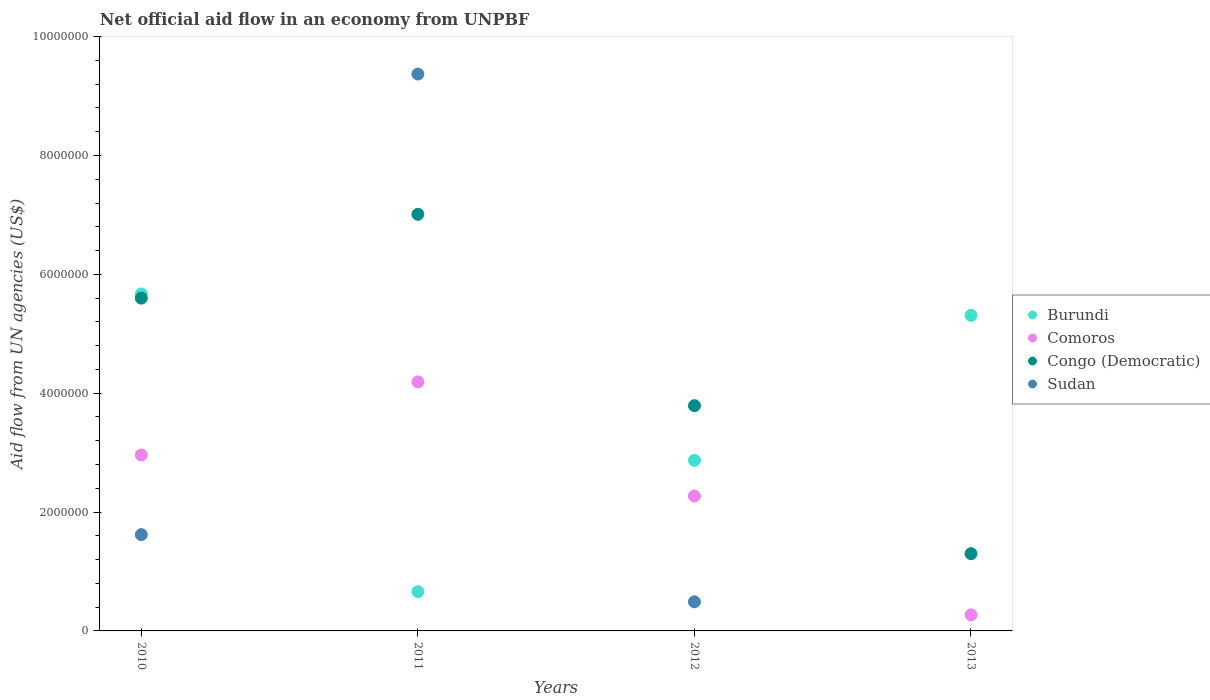How many different coloured dotlines are there?
Give a very brief answer. 4. What is the net official aid flow in Burundi in 2011?
Keep it short and to the point. 6.60e+05. Across all years, what is the maximum net official aid flow in Congo (Democratic)?
Provide a short and direct response. 7.01e+06. Across all years, what is the minimum net official aid flow in Congo (Democratic)?
Ensure brevity in your answer.  1.30e+06. What is the total net official aid flow in Comoros in the graph?
Provide a succinct answer. 9.69e+06. What is the difference between the net official aid flow in Congo (Democratic) in 2010 and that in 2013?
Provide a short and direct response. 4.30e+06. What is the difference between the net official aid flow in Comoros in 2013 and the net official aid flow in Burundi in 2010?
Your response must be concise. -5.40e+06. What is the average net official aid flow in Congo (Democratic) per year?
Provide a succinct answer. 4.42e+06. In the year 2012, what is the difference between the net official aid flow in Congo (Democratic) and net official aid flow in Burundi?
Provide a succinct answer. 9.20e+05. What is the ratio of the net official aid flow in Burundi in 2010 to that in 2012?
Your answer should be very brief. 1.98. What is the difference between the highest and the second highest net official aid flow in Burundi?
Your response must be concise. 3.60e+05. What is the difference between the highest and the lowest net official aid flow in Congo (Democratic)?
Keep it short and to the point. 5.71e+06. Is it the case that in every year, the sum of the net official aid flow in Burundi and net official aid flow in Comoros  is greater than the sum of net official aid flow in Sudan and net official aid flow in Congo (Democratic)?
Keep it short and to the point. No. Is it the case that in every year, the sum of the net official aid flow in Sudan and net official aid flow in Burundi  is greater than the net official aid flow in Congo (Democratic)?
Provide a short and direct response. No. Does the net official aid flow in Congo (Democratic) monotonically increase over the years?
Ensure brevity in your answer.  No. Is the net official aid flow in Congo (Democratic) strictly less than the net official aid flow in Sudan over the years?
Offer a terse response. No. What is the difference between two consecutive major ticks on the Y-axis?
Provide a short and direct response. 2.00e+06. How many legend labels are there?
Keep it short and to the point. 4. How are the legend labels stacked?
Ensure brevity in your answer.  Vertical. What is the title of the graph?
Ensure brevity in your answer.  Net official aid flow in an economy from UNPBF. What is the label or title of the Y-axis?
Your response must be concise. Aid flow from UN agencies (US$). What is the Aid flow from UN agencies (US$) of Burundi in 2010?
Offer a terse response. 5.67e+06. What is the Aid flow from UN agencies (US$) of Comoros in 2010?
Ensure brevity in your answer.  2.96e+06. What is the Aid flow from UN agencies (US$) of Congo (Democratic) in 2010?
Your answer should be very brief. 5.60e+06. What is the Aid flow from UN agencies (US$) in Sudan in 2010?
Your response must be concise. 1.62e+06. What is the Aid flow from UN agencies (US$) in Comoros in 2011?
Keep it short and to the point. 4.19e+06. What is the Aid flow from UN agencies (US$) in Congo (Democratic) in 2011?
Keep it short and to the point. 7.01e+06. What is the Aid flow from UN agencies (US$) of Sudan in 2011?
Make the answer very short. 9.37e+06. What is the Aid flow from UN agencies (US$) in Burundi in 2012?
Your answer should be very brief. 2.87e+06. What is the Aid flow from UN agencies (US$) of Comoros in 2012?
Offer a very short reply. 2.27e+06. What is the Aid flow from UN agencies (US$) of Congo (Democratic) in 2012?
Offer a terse response. 3.79e+06. What is the Aid flow from UN agencies (US$) in Sudan in 2012?
Provide a succinct answer. 4.90e+05. What is the Aid flow from UN agencies (US$) in Burundi in 2013?
Your answer should be very brief. 5.31e+06. What is the Aid flow from UN agencies (US$) in Congo (Democratic) in 2013?
Provide a short and direct response. 1.30e+06. What is the Aid flow from UN agencies (US$) in Sudan in 2013?
Your answer should be very brief. 0. Across all years, what is the maximum Aid flow from UN agencies (US$) in Burundi?
Provide a short and direct response. 5.67e+06. Across all years, what is the maximum Aid flow from UN agencies (US$) of Comoros?
Offer a very short reply. 4.19e+06. Across all years, what is the maximum Aid flow from UN agencies (US$) of Congo (Democratic)?
Your answer should be very brief. 7.01e+06. Across all years, what is the maximum Aid flow from UN agencies (US$) in Sudan?
Give a very brief answer. 9.37e+06. Across all years, what is the minimum Aid flow from UN agencies (US$) in Burundi?
Make the answer very short. 6.60e+05. Across all years, what is the minimum Aid flow from UN agencies (US$) in Congo (Democratic)?
Your answer should be very brief. 1.30e+06. What is the total Aid flow from UN agencies (US$) of Burundi in the graph?
Your response must be concise. 1.45e+07. What is the total Aid flow from UN agencies (US$) in Comoros in the graph?
Your response must be concise. 9.69e+06. What is the total Aid flow from UN agencies (US$) of Congo (Democratic) in the graph?
Offer a very short reply. 1.77e+07. What is the total Aid flow from UN agencies (US$) in Sudan in the graph?
Keep it short and to the point. 1.15e+07. What is the difference between the Aid flow from UN agencies (US$) in Burundi in 2010 and that in 2011?
Offer a terse response. 5.01e+06. What is the difference between the Aid flow from UN agencies (US$) in Comoros in 2010 and that in 2011?
Offer a very short reply. -1.23e+06. What is the difference between the Aid flow from UN agencies (US$) of Congo (Democratic) in 2010 and that in 2011?
Your answer should be compact. -1.41e+06. What is the difference between the Aid flow from UN agencies (US$) of Sudan in 2010 and that in 2011?
Your answer should be very brief. -7.75e+06. What is the difference between the Aid flow from UN agencies (US$) of Burundi in 2010 and that in 2012?
Your answer should be very brief. 2.80e+06. What is the difference between the Aid flow from UN agencies (US$) of Comoros in 2010 and that in 2012?
Give a very brief answer. 6.90e+05. What is the difference between the Aid flow from UN agencies (US$) in Congo (Democratic) in 2010 and that in 2012?
Your response must be concise. 1.81e+06. What is the difference between the Aid flow from UN agencies (US$) in Sudan in 2010 and that in 2012?
Keep it short and to the point. 1.13e+06. What is the difference between the Aid flow from UN agencies (US$) of Comoros in 2010 and that in 2013?
Keep it short and to the point. 2.69e+06. What is the difference between the Aid flow from UN agencies (US$) of Congo (Democratic) in 2010 and that in 2013?
Make the answer very short. 4.30e+06. What is the difference between the Aid flow from UN agencies (US$) of Burundi in 2011 and that in 2012?
Your response must be concise. -2.21e+06. What is the difference between the Aid flow from UN agencies (US$) in Comoros in 2011 and that in 2012?
Provide a succinct answer. 1.92e+06. What is the difference between the Aid flow from UN agencies (US$) of Congo (Democratic) in 2011 and that in 2012?
Provide a short and direct response. 3.22e+06. What is the difference between the Aid flow from UN agencies (US$) in Sudan in 2011 and that in 2012?
Give a very brief answer. 8.88e+06. What is the difference between the Aid flow from UN agencies (US$) in Burundi in 2011 and that in 2013?
Your response must be concise. -4.65e+06. What is the difference between the Aid flow from UN agencies (US$) in Comoros in 2011 and that in 2013?
Your response must be concise. 3.92e+06. What is the difference between the Aid flow from UN agencies (US$) of Congo (Democratic) in 2011 and that in 2013?
Make the answer very short. 5.71e+06. What is the difference between the Aid flow from UN agencies (US$) of Burundi in 2012 and that in 2013?
Offer a very short reply. -2.44e+06. What is the difference between the Aid flow from UN agencies (US$) in Comoros in 2012 and that in 2013?
Your answer should be very brief. 2.00e+06. What is the difference between the Aid flow from UN agencies (US$) of Congo (Democratic) in 2012 and that in 2013?
Give a very brief answer. 2.49e+06. What is the difference between the Aid flow from UN agencies (US$) of Burundi in 2010 and the Aid flow from UN agencies (US$) of Comoros in 2011?
Offer a very short reply. 1.48e+06. What is the difference between the Aid flow from UN agencies (US$) in Burundi in 2010 and the Aid flow from UN agencies (US$) in Congo (Democratic) in 2011?
Give a very brief answer. -1.34e+06. What is the difference between the Aid flow from UN agencies (US$) in Burundi in 2010 and the Aid flow from UN agencies (US$) in Sudan in 2011?
Provide a succinct answer. -3.70e+06. What is the difference between the Aid flow from UN agencies (US$) of Comoros in 2010 and the Aid flow from UN agencies (US$) of Congo (Democratic) in 2011?
Give a very brief answer. -4.05e+06. What is the difference between the Aid flow from UN agencies (US$) in Comoros in 2010 and the Aid flow from UN agencies (US$) in Sudan in 2011?
Your answer should be compact. -6.41e+06. What is the difference between the Aid flow from UN agencies (US$) in Congo (Democratic) in 2010 and the Aid flow from UN agencies (US$) in Sudan in 2011?
Offer a very short reply. -3.77e+06. What is the difference between the Aid flow from UN agencies (US$) in Burundi in 2010 and the Aid flow from UN agencies (US$) in Comoros in 2012?
Your answer should be very brief. 3.40e+06. What is the difference between the Aid flow from UN agencies (US$) in Burundi in 2010 and the Aid flow from UN agencies (US$) in Congo (Democratic) in 2012?
Offer a terse response. 1.88e+06. What is the difference between the Aid flow from UN agencies (US$) of Burundi in 2010 and the Aid flow from UN agencies (US$) of Sudan in 2012?
Your answer should be very brief. 5.18e+06. What is the difference between the Aid flow from UN agencies (US$) of Comoros in 2010 and the Aid flow from UN agencies (US$) of Congo (Democratic) in 2012?
Make the answer very short. -8.30e+05. What is the difference between the Aid flow from UN agencies (US$) in Comoros in 2010 and the Aid flow from UN agencies (US$) in Sudan in 2012?
Your response must be concise. 2.47e+06. What is the difference between the Aid flow from UN agencies (US$) of Congo (Democratic) in 2010 and the Aid flow from UN agencies (US$) of Sudan in 2012?
Provide a succinct answer. 5.11e+06. What is the difference between the Aid flow from UN agencies (US$) in Burundi in 2010 and the Aid flow from UN agencies (US$) in Comoros in 2013?
Your answer should be compact. 5.40e+06. What is the difference between the Aid flow from UN agencies (US$) in Burundi in 2010 and the Aid flow from UN agencies (US$) in Congo (Democratic) in 2013?
Offer a terse response. 4.37e+06. What is the difference between the Aid flow from UN agencies (US$) in Comoros in 2010 and the Aid flow from UN agencies (US$) in Congo (Democratic) in 2013?
Make the answer very short. 1.66e+06. What is the difference between the Aid flow from UN agencies (US$) in Burundi in 2011 and the Aid flow from UN agencies (US$) in Comoros in 2012?
Provide a succinct answer. -1.61e+06. What is the difference between the Aid flow from UN agencies (US$) of Burundi in 2011 and the Aid flow from UN agencies (US$) of Congo (Democratic) in 2012?
Your answer should be compact. -3.13e+06. What is the difference between the Aid flow from UN agencies (US$) in Comoros in 2011 and the Aid flow from UN agencies (US$) in Sudan in 2012?
Provide a succinct answer. 3.70e+06. What is the difference between the Aid flow from UN agencies (US$) of Congo (Democratic) in 2011 and the Aid flow from UN agencies (US$) of Sudan in 2012?
Provide a succinct answer. 6.52e+06. What is the difference between the Aid flow from UN agencies (US$) in Burundi in 2011 and the Aid flow from UN agencies (US$) in Congo (Democratic) in 2013?
Make the answer very short. -6.40e+05. What is the difference between the Aid flow from UN agencies (US$) in Comoros in 2011 and the Aid flow from UN agencies (US$) in Congo (Democratic) in 2013?
Provide a short and direct response. 2.89e+06. What is the difference between the Aid flow from UN agencies (US$) of Burundi in 2012 and the Aid flow from UN agencies (US$) of Comoros in 2013?
Keep it short and to the point. 2.60e+06. What is the difference between the Aid flow from UN agencies (US$) of Burundi in 2012 and the Aid flow from UN agencies (US$) of Congo (Democratic) in 2013?
Your response must be concise. 1.57e+06. What is the difference between the Aid flow from UN agencies (US$) of Comoros in 2012 and the Aid flow from UN agencies (US$) of Congo (Democratic) in 2013?
Give a very brief answer. 9.70e+05. What is the average Aid flow from UN agencies (US$) in Burundi per year?
Ensure brevity in your answer.  3.63e+06. What is the average Aid flow from UN agencies (US$) in Comoros per year?
Give a very brief answer. 2.42e+06. What is the average Aid flow from UN agencies (US$) of Congo (Democratic) per year?
Keep it short and to the point. 4.42e+06. What is the average Aid flow from UN agencies (US$) in Sudan per year?
Give a very brief answer. 2.87e+06. In the year 2010, what is the difference between the Aid flow from UN agencies (US$) in Burundi and Aid flow from UN agencies (US$) in Comoros?
Make the answer very short. 2.71e+06. In the year 2010, what is the difference between the Aid flow from UN agencies (US$) of Burundi and Aid flow from UN agencies (US$) of Congo (Democratic)?
Offer a terse response. 7.00e+04. In the year 2010, what is the difference between the Aid flow from UN agencies (US$) of Burundi and Aid flow from UN agencies (US$) of Sudan?
Provide a succinct answer. 4.05e+06. In the year 2010, what is the difference between the Aid flow from UN agencies (US$) of Comoros and Aid flow from UN agencies (US$) of Congo (Democratic)?
Your answer should be very brief. -2.64e+06. In the year 2010, what is the difference between the Aid flow from UN agencies (US$) in Comoros and Aid flow from UN agencies (US$) in Sudan?
Your answer should be compact. 1.34e+06. In the year 2010, what is the difference between the Aid flow from UN agencies (US$) in Congo (Democratic) and Aid flow from UN agencies (US$) in Sudan?
Offer a terse response. 3.98e+06. In the year 2011, what is the difference between the Aid flow from UN agencies (US$) of Burundi and Aid flow from UN agencies (US$) of Comoros?
Make the answer very short. -3.53e+06. In the year 2011, what is the difference between the Aid flow from UN agencies (US$) in Burundi and Aid flow from UN agencies (US$) in Congo (Democratic)?
Make the answer very short. -6.35e+06. In the year 2011, what is the difference between the Aid flow from UN agencies (US$) in Burundi and Aid flow from UN agencies (US$) in Sudan?
Offer a very short reply. -8.71e+06. In the year 2011, what is the difference between the Aid flow from UN agencies (US$) in Comoros and Aid flow from UN agencies (US$) in Congo (Democratic)?
Your answer should be compact. -2.82e+06. In the year 2011, what is the difference between the Aid flow from UN agencies (US$) of Comoros and Aid flow from UN agencies (US$) of Sudan?
Your answer should be very brief. -5.18e+06. In the year 2011, what is the difference between the Aid flow from UN agencies (US$) of Congo (Democratic) and Aid flow from UN agencies (US$) of Sudan?
Offer a very short reply. -2.36e+06. In the year 2012, what is the difference between the Aid flow from UN agencies (US$) in Burundi and Aid flow from UN agencies (US$) in Congo (Democratic)?
Provide a short and direct response. -9.20e+05. In the year 2012, what is the difference between the Aid flow from UN agencies (US$) of Burundi and Aid flow from UN agencies (US$) of Sudan?
Ensure brevity in your answer.  2.38e+06. In the year 2012, what is the difference between the Aid flow from UN agencies (US$) in Comoros and Aid flow from UN agencies (US$) in Congo (Democratic)?
Give a very brief answer. -1.52e+06. In the year 2012, what is the difference between the Aid flow from UN agencies (US$) of Comoros and Aid flow from UN agencies (US$) of Sudan?
Your answer should be very brief. 1.78e+06. In the year 2012, what is the difference between the Aid flow from UN agencies (US$) of Congo (Democratic) and Aid flow from UN agencies (US$) of Sudan?
Make the answer very short. 3.30e+06. In the year 2013, what is the difference between the Aid flow from UN agencies (US$) of Burundi and Aid flow from UN agencies (US$) of Comoros?
Offer a very short reply. 5.04e+06. In the year 2013, what is the difference between the Aid flow from UN agencies (US$) in Burundi and Aid flow from UN agencies (US$) in Congo (Democratic)?
Your answer should be very brief. 4.01e+06. In the year 2013, what is the difference between the Aid flow from UN agencies (US$) in Comoros and Aid flow from UN agencies (US$) in Congo (Democratic)?
Give a very brief answer. -1.03e+06. What is the ratio of the Aid flow from UN agencies (US$) in Burundi in 2010 to that in 2011?
Provide a short and direct response. 8.59. What is the ratio of the Aid flow from UN agencies (US$) in Comoros in 2010 to that in 2011?
Make the answer very short. 0.71. What is the ratio of the Aid flow from UN agencies (US$) of Congo (Democratic) in 2010 to that in 2011?
Offer a very short reply. 0.8. What is the ratio of the Aid flow from UN agencies (US$) in Sudan in 2010 to that in 2011?
Give a very brief answer. 0.17. What is the ratio of the Aid flow from UN agencies (US$) of Burundi in 2010 to that in 2012?
Offer a terse response. 1.98. What is the ratio of the Aid flow from UN agencies (US$) of Comoros in 2010 to that in 2012?
Your answer should be very brief. 1.3. What is the ratio of the Aid flow from UN agencies (US$) in Congo (Democratic) in 2010 to that in 2012?
Provide a short and direct response. 1.48. What is the ratio of the Aid flow from UN agencies (US$) in Sudan in 2010 to that in 2012?
Provide a succinct answer. 3.31. What is the ratio of the Aid flow from UN agencies (US$) in Burundi in 2010 to that in 2013?
Provide a succinct answer. 1.07. What is the ratio of the Aid flow from UN agencies (US$) of Comoros in 2010 to that in 2013?
Your answer should be compact. 10.96. What is the ratio of the Aid flow from UN agencies (US$) in Congo (Democratic) in 2010 to that in 2013?
Provide a succinct answer. 4.31. What is the ratio of the Aid flow from UN agencies (US$) in Burundi in 2011 to that in 2012?
Offer a terse response. 0.23. What is the ratio of the Aid flow from UN agencies (US$) of Comoros in 2011 to that in 2012?
Give a very brief answer. 1.85. What is the ratio of the Aid flow from UN agencies (US$) of Congo (Democratic) in 2011 to that in 2012?
Provide a short and direct response. 1.85. What is the ratio of the Aid flow from UN agencies (US$) of Sudan in 2011 to that in 2012?
Give a very brief answer. 19.12. What is the ratio of the Aid flow from UN agencies (US$) of Burundi in 2011 to that in 2013?
Offer a terse response. 0.12. What is the ratio of the Aid flow from UN agencies (US$) in Comoros in 2011 to that in 2013?
Your answer should be very brief. 15.52. What is the ratio of the Aid flow from UN agencies (US$) of Congo (Democratic) in 2011 to that in 2013?
Offer a terse response. 5.39. What is the ratio of the Aid flow from UN agencies (US$) of Burundi in 2012 to that in 2013?
Offer a terse response. 0.54. What is the ratio of the Aid flow from UN agencies (US$) of Comoros in 2012 to that in 2013?
Offer a terse response. 8.41. What is the ratio of the Aid flow from UN agencies (US$) of Congo (Democratic) in 2012 to that in 2013?
Your response must be concise. 2.92. What is the difference between the highest and the second highest Aid flow from UN agencies (US$) in Comoros?
Provide a succinct answer. 1.23e+06. What is the difference between the highest and the second highest Aid flow from UN agencies (US$) of Congo (Democratic)?
Offer a terse response. 1.41e+06. What is the difference between the highest and the second highest Aid flow from UN agencies (US$) in Sudan?
Offer a terse response. 7.75e+06. What is the difference between the highest and the lowest Aid flow from UN agencies (US$) in Burundi?
Provide a succinct answer. 5.01e+06. What is the difference between the highest and the lowest Aid flow from UN agencies (US$) in Comoros?
Your answer should be very brief. 3.92e+06. What is the difference between the highest and the lowest Aid flow from UN agencies (US$) in Congo (Democratic)?
Offer a very short reply. 5.71e+06. What is the difference between the highest and the lowest Aid flow from UN agencies (US$) in Sudan?
Your answer should be compact. 9.37e+06. 